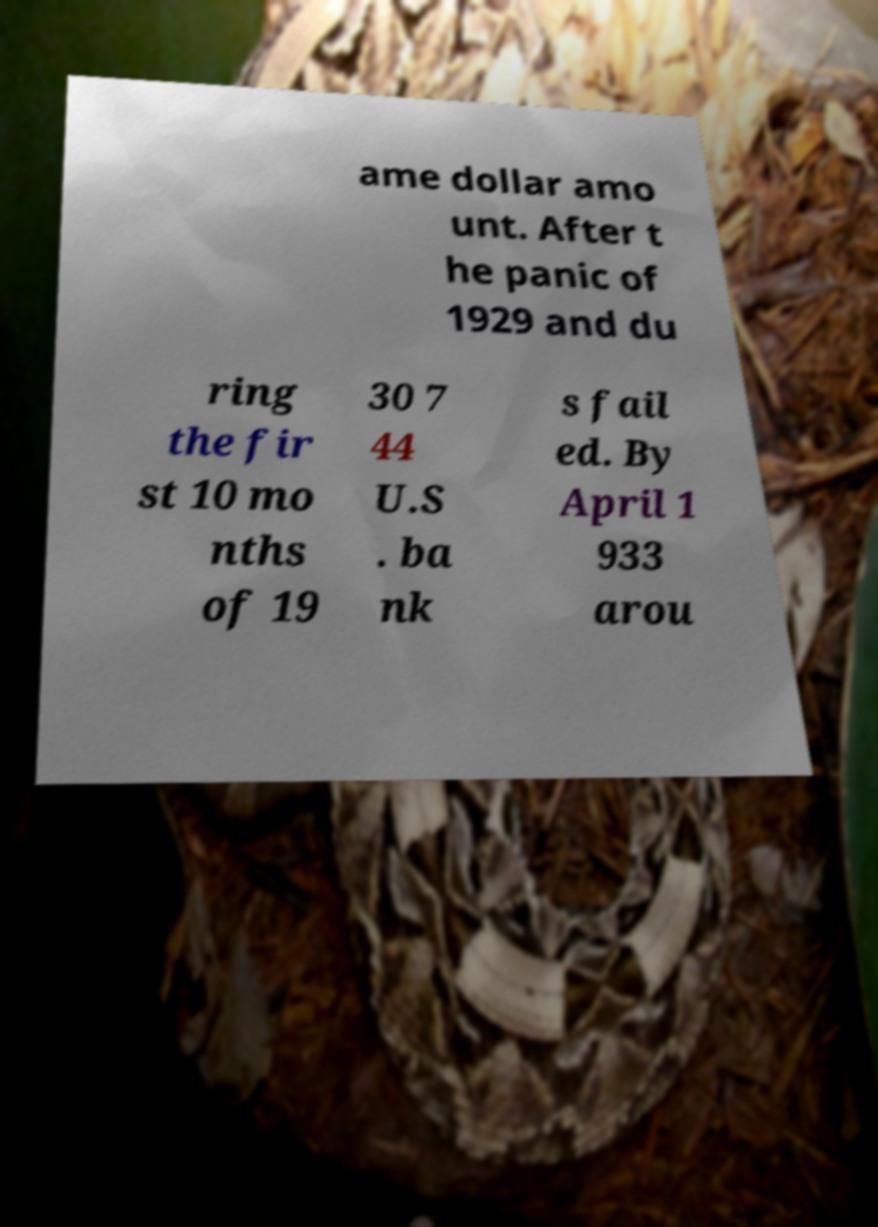Can you read and provide the text displayed in the image?This photo seems to have some interesting text. Can you extract and type it out for me? ame dollar amo unt. After t he panic of 1929 and du ring the fir st 10 mo nths of 19 30 7 44 U.S . ba nk s fail ed. By April 1 933 arou 